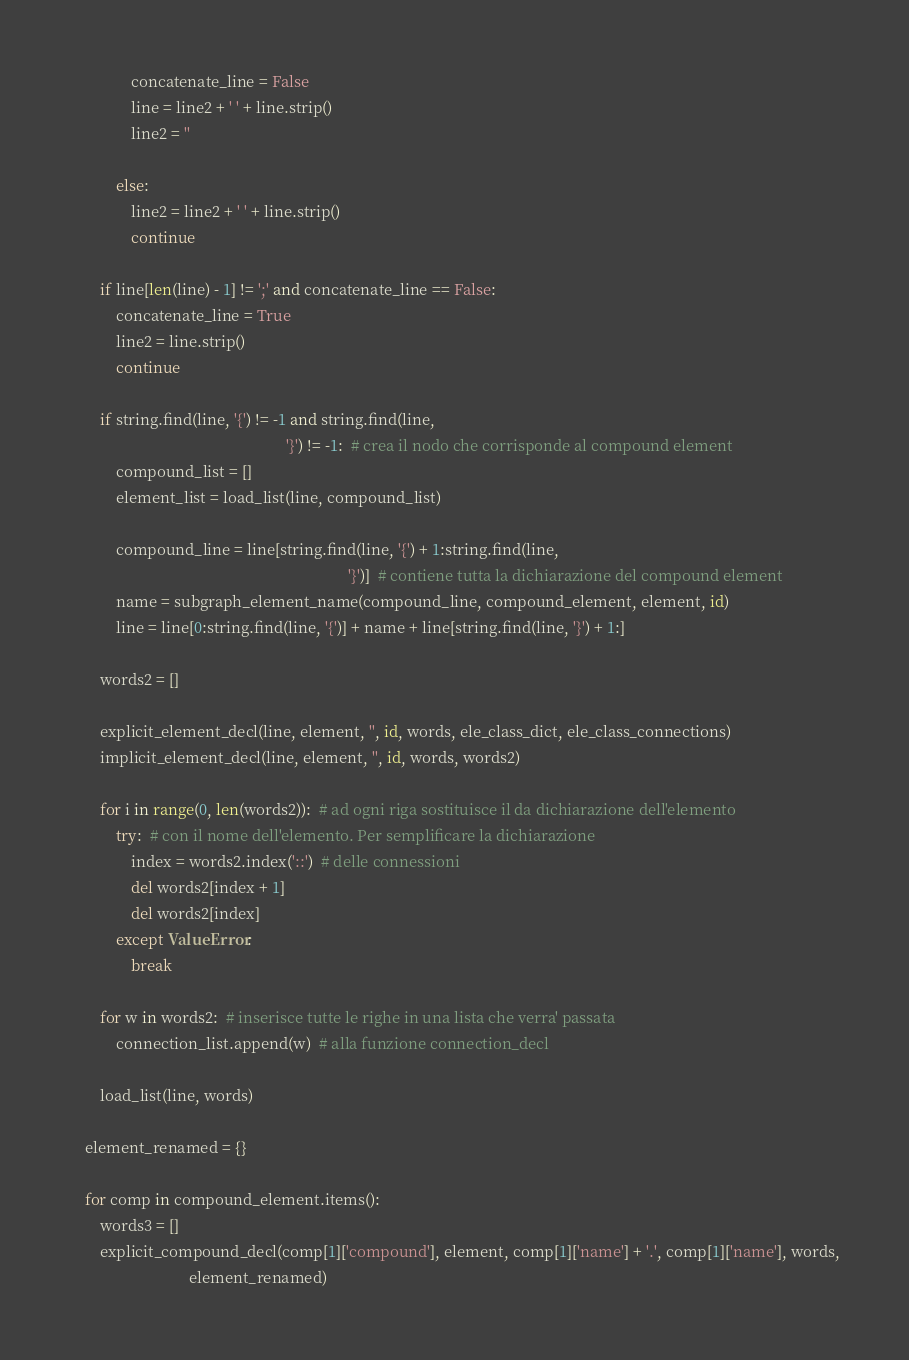Convert code to text. <code><loc_0><loc_0><loc_500><loc_500><_Python_>                concatenate_line = False
                line = line2 + ' ' + line.strip()
                line2 = ''

            else:
                line2 = line2 + ' ' + line.strip()
                continue

        if line[len(line) - 1] != ';' and concatenate_line == False:
            concatenate_line = True
            line2 = line.strip()
            continue

        if string.find(line, '{') != -1 and string.find(line,
                                                        '}') != -1:  # crea il nodo che corrisponde al compound element
            compound_list = []
            element_list = load_list(line, compound_list)

            compound_line = line[string.find(line, '{') + 1:string.find(line,
                                                                        '}')]  # contiene tutta la dichiarazione del compound element
            name = subgraph_element_name(compound_line, compound_element, element, id)
            line = line[0:string.find(line, '{')] + name + line[string.find(line, '}') + 1:]

        words2 = []

        explicit_element_decl(line, element, '', id, words, ele_class_dict, ele_class_connections)
        implicit_element_decl(line, element, '', id, words, words2)

        for i in range(0, len(words2)):  # ad ogni riga sostituisce il da dichiarazione dell'elemento
            try:  # con il nome dell'elemento. Per semplificare la dichiarazione
                index = words2.index('::')  # delle connessioni
                del words2[index + 1]
                del words2[index]
            except ValueError:
                break

        for w in words2:  # inserisce tutte le righe in una lista che verra' passata
            connection_list.append(w)  # alla funzione connection_decl

        load_list(line, words)

    element_renamed = {}

    for comp in compound_element.items():
        words3 = []
        explicit_compound_decl(comp[1]['compound'], element, comp[1]['name'] + '.', comp[1]['name'], words,
                               element_renamed)</code> 